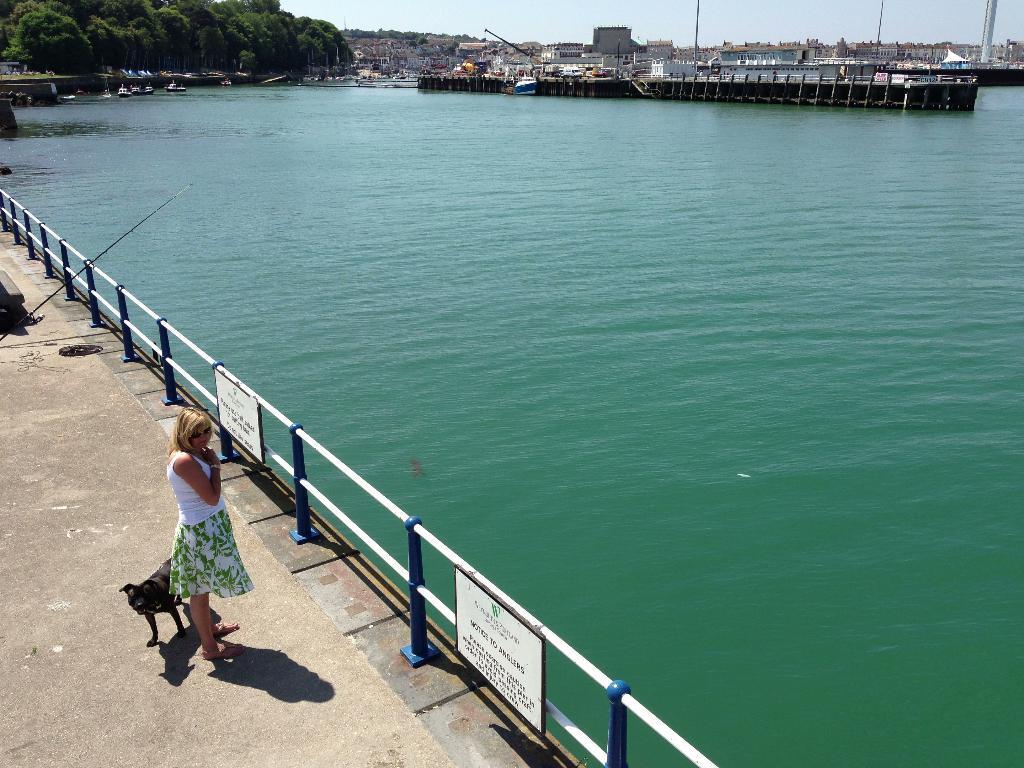How would you summarize this image in a sentence or two? On the left side, there is a woman in white color T-shirt, standing on a platform. Beside her, there is a dog. In front of her, there is a fence, on which there are two hoardings attached. On the right side, there is water. In the background, there are boats on the water, there are buildings and there is sky. 